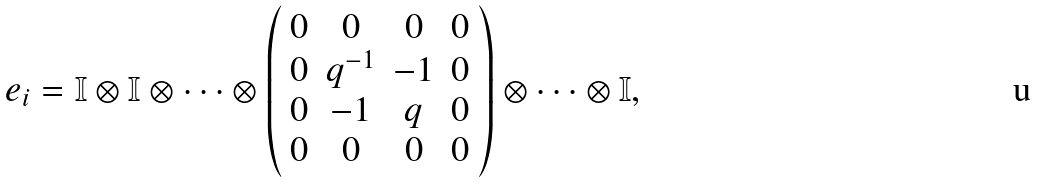<formula> <loc_0><loc_0><loc_500><loc_500>e _ { i } = \mathbb { I } \otimes \mathbb { I } \otimes \dots \otimes \left ( \begin{array} { c c c c } 0 & 0 & 0 & 0 \\ 0 & q ^ { - 1 } & - 1 & 0 \\ 0 & - 1 & q & 0 \\ 0 & 0 & 0 & 0 \end{array} \right ) \otimes \dots \otimes \mathbb { I } ,</formula> 